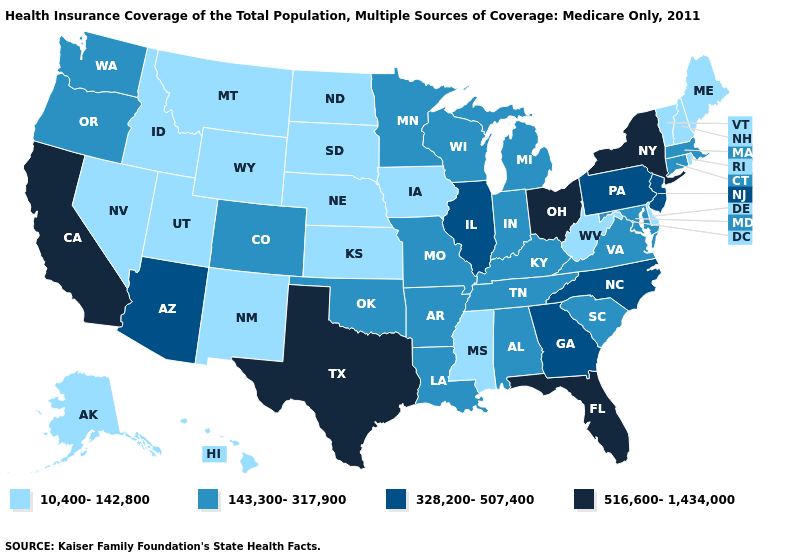How many symbols are there in the legend?
Concise answer only. 4. Does New Hampshire have the same value as Wisconsin?
Give a very brief answer. No. Does the map have missing data?
Keep it brief. No. Name the states that have a value in the range 143,300-317,900?
Short answer required. Alabama, Arkansas, Colorado, Connecticut, Indiana, Kentucky, Louisiana, Maryland, Massachusetts, Michigan, Minnesota, Missouri, Oklahoma, Oregon, South Carolina, Tennessee, Virginia, Washington, Wisconsin. What is the value of Utah?
Be succinct. 10,400-142,800. Name the states that have a value in the range 143,300-317,900?
Short answer required. Alabama, Arkansas, Colorado, Connecticut, Indiana, Kentucky, Louisiana, Maryland, Massachusetts, Michigan, Minnesota, Missouri, Oklahoma, Oregon, South Carolina, Tennessee, Virginia, Washington, Wisconsin. Among the states that border Virginia , does Tennessee have the highest value?
Keep it brief. No. Is the legend a continuous bar?
Be succinct. No. Which states have the lowest value in the USA?
Keep it brief. Alaska, Delaware, Hawaii, Idaho, Iowa, Kansas, Maine, Mississippi, Montana, Nebraska, Nevada, New Hampshire, New Mexico, North Dakota, Rhode Island, South Dakota, Utah, Vermont, West Virginia, Wyoming. Name the states that have a value in the range 143,300-317,900?
Be succinct. Alabama, Arkansas, Colorado, Connecticut, Indiana, Kentucky, Louisiana, Maryland, Massachusetts, Michigan, Minnesota, Missouri, Oklahoma, Oregon, South Carolina, Tennessee, Virginia, Washington, Wisconsin. Does Ohio have the highest value in the USA?
Answer briefly. Yes. What is the lowest value in the Northeast?
Be succinct. 10,400-142,800. Does Nevada have the lowest value in the USA?
Keep it brief. Yes. Name the states that have a value in the range 10,400-142,800?
Be succinct. Alaska, Delaware, Hawaii, Idaho, Iowa, Kansas, Maine, Mississippi, Montana, Nebraska, Nevada, New Hampshire, New Mexico, North Dakota, Rhode Island, South Dakota, Utah, Vermont, West Virginia, Wyoming. What is the value of Massachusetts?
Concise answer only. 143,300-317,900. 